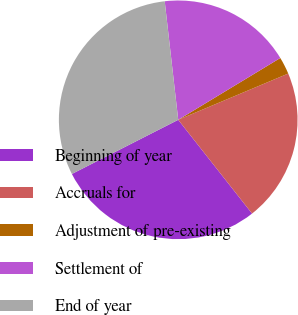Convert chart to OTSL. <chart><loc_0><loc_0><loc_500><loc_500><pie_chart><fcel>Beginning of year<fcel>Accruals for<fcel>Adjustment of pre-existing<fcel>Settlement of<fcel>End of year<nl><fcel>28.12%<fcel>20.72%<fcel>2.33%<fcel>18.14%<fcel>30.69%<nl></chart> 